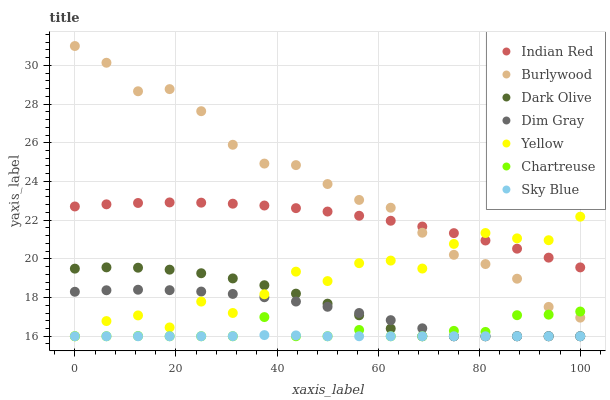Does Sky Blue have the minimum area under the curve?
Answer yes or no. Yes. Does Burlywood have the maximum area under the curve?
Answer yes or no. Yes. Does Dark Olive have the minimum area under the curve?
Answer yes or no. No. Does Dark Olive have the maximum area under the curve?
Answer yes or no. No. Is Sky Blue the smoothest?
Answer yes or no. Yes. Is Yellow the roughest?
Answer yes or no. Yes. Is Burlywood the smoothest?
Answer yes or no. No. Is Burlywood the roughest?
Answer yes or no. No. Does Dim Gray have the lowest value?
Answer yes or no. Yes. Does Burlywood have the lowest value?
Answer yes or no. No. Does Burlywood have the highest value?
Answer yes or no. Yes. Does Dark Olive have the highest value?
Answer yes or no. No. Is Sky Blue less than Burlywood?
Answer yes or no. Yes. Is Burlywood greater than Dark Olive?
Answer yes or no. Yes. Does Dim Gray intersect Yellow?
Answer yes or no. Yes. Is Dim Gray less than Yellow?
Answer yes or no. No. Is Dim Gray greater than Yellow?
Answer yes or no. No. Does Sky Blue intersect Burlywood?
Answer yes or no. No. 